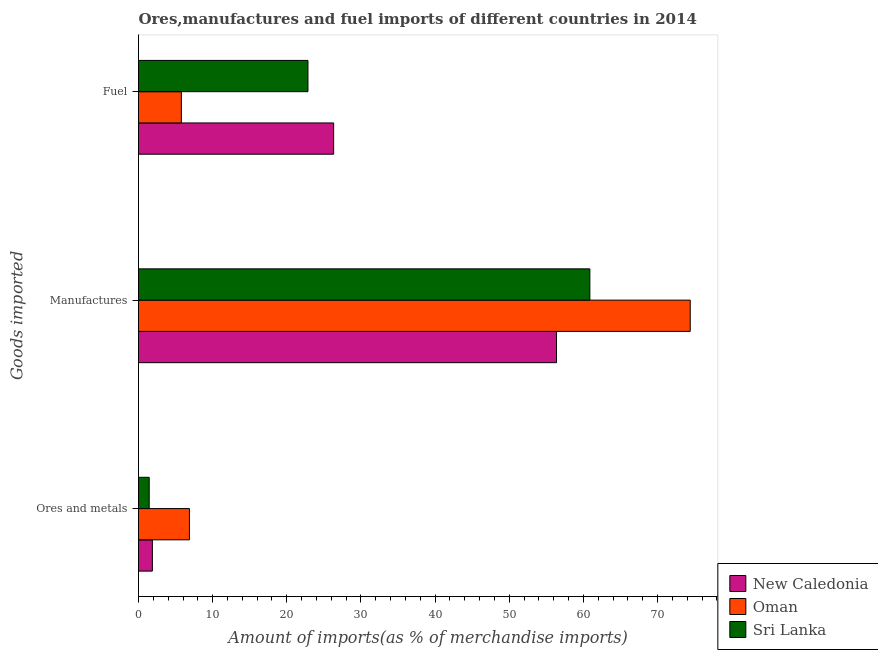How many groups of bars are there?
Your answer should be compact. 3. How many bars are there on the 1st tick from the bottom?
Your answer should be very brief. 3. What is the label of the 1st group of bars from the top?
Your answer should be very brief. Fuel. What is the percentage of manufactures imports in New Caledonia?
Offer a terse response. 56.38. Across all countries, what is the maximum percentage of fuel imports?
Provide a succinct answer. 26.32. Across all countries, what is the minimum percentage of ores and metals imports?
Make the answer very short. 1.44. In which country was the percentage of fuel imports maximum?
Provide a succinct answer. New Caledonia. In which country was the percentage of ores and metals imports minimum?
Your answer should be very brief. Sri Lanka. What is the total percentage of ores and metals imports in the graph?
Make the answer very short. 10.18. What is the difference between the percentage of ores and metals imports in Sri Lanka and that in New Caledonia?
Provide a short and direct response. -0.43. What is the difference between the percentage of ores and metals imports in Sri Lanka and the percentage of fuel imports in New Caledonia?
Provide a succinct answer. -24.88. What is the average percentage of ores and metals imports per country?
Offer a very short reply. 3.39. What is the difference between the percentage of fuel imports and percentage of manufactures imports in Oman?
Give a very brief answer. -68.63. In how many countries, is the percentage of fuel imports greater than 38 %?
Provide a succinct answer. 0. What is the ratio of the percentage of ores and metals imports in Sri Lanka to that in New Caledonia?
Offer a terse response. 0.77. Is the difference between the percentage of ores and metals imports in New Caledonia and Sri Lanka greater than the difference between the percentage of fuel imports in New Caledonia and Sri Lanka?
Give a very brief answer. No. What is the difference between the highest and the second highest percentage of ores and metals imports?
Provide a succinct answer. 5. What is the difference between the highest and the lowest percentage of ores and metals imports?
Your response must be concise. 5.43. What does the 3rd bar from the top in Ores and metals represents?
Offer a terse response. New Caledonia. What does the 2nd bar from the bottom in Manufactures represents?
Your answer should be very brief. Oman. Is it the case that in every country, the sum of the percentage of ores and metals imports and percentage of manufactures imports is greater than the percentage of fuel imports?
Offer a terse response. Yes. How many bars are there?
Provide a succinct answer. 9. How many countries are there in the graph?
Make the answer very short. 3. Are the values on the major ticks of X-axis written in scientific E-notation?
Provide a succinct answer. No. Does the graph contain grids?
Offer a terse response. No. How many legend labels are there?
Your response must be concise. 3. What is the title of the graph?
Give a very brief answer. Ores,manufactures and fuel imports of different countries in 2014. What is the label or title of the X-axis?
Provide a succinct answer. Amount of imports(as % of merchandise imports). What is the label or title of the Y-axis?
Your response must be concise. Goods imported. What is the Amount of imports(as % of merchandise imports) of New Caledonia in Ores and metals?
Provide a succinct answer. 1.87. What is the Amount of imports(as % of merchandise imports) in Oman in Ores and metals?
Your answer should be compact. 6.87. What is the Amount of imports(as % of merchandise imports) in Sri Lanka in Ores and metals?
Provide a short and direct response. 1.44. What is the Amount of imports(as % of merchandise imports) in New Caledonia in Manufactures?
Provide a succinct answer. 56.38. What is the Amount of imports(as % of merchandise imports) in Oman in Manufactures?
Ensure brevity in your answer.  74.41. What is the Amount of imports(as % of merchandise imports) in Sri Lanka in Manufactures?
Your answer should be compact. 60.88. What is the Amount of imports(as % of merchandise imports) of New Caledonia in Fuel?
Ensure brevity in your answer.  26.32. What is the Amount of imports(as % of merchandise imports) in Oman in Fuel?
Your response must be concise. 5.78. What is the Amount of imports(as % of merchandise imports) of Sri Lanka in Fuel?
Your response must be concise. 22.85. Across all Goods imported, what is the maximum Amount of imports(as % of merchandise imports) in New Caledonia?
Provide a succinct answer. 56.38. Across all Goods imported, what is the maximum Amount of imports(as % of merchandise imports) in Oman?
Offer a terse response. 74.41. Across all Goods imported, what is the maximum Amount of imports(as % of merchandise imports) in Sri Lanka?
Your answer should be very brief. 60.88. Across all Goods imported, what is the minimum Amount of imports(as % of merchandise imports) in New Caledonia?
Provide a short and direct response. 1.87. Across all Goods imported, what is the minimum Amount of imports(as % of merchandise imports) in Oman?
Ensure brevity in your answer.  5.78. Across all Goods imported, what is the minimum Amount of imports(as % of merchandise imports) of Sri Lanka?
Your answer should be very brief. 1.44. What is the total Amount of imports(as % of merchandise imports) of New Caledonia in the graph?
Make the answer very short. 84.57. What is the total Amount of imports(as % of merchandise imports) of Oman in the graph?
Make the answer very short. 87.06. What is the total Amount of imports(as % of merchandise imports) of Sri Lanka in the graph?
Provide a succinct answer. 85.17. What is the difference between the Amount of imports(as % of merchandise imports) of New Caledonia in Ores and metals and that in Manufactures?
Give a very brief answer. -54.51. What is the difference between the Amount of imports(as % of merchandise imports) in Oman in Ores and metals and that in Manufactures?
Your response must be concise. -67.54. What is the difference between the Amount of imports(as % of merchandise imports) of Sri Lanka in Ores and metals and that in Manufactures?
Keep it short and to the point. -59.43. What is the difference between the Amount of imports(as % of merchandise imports) in New Caledonia in Ores and metals and that in Fuel?
Offer a very short reply. -24.45. What is the difference between the Amount of imports(as % of merchandise imports) of Oman in Ores and metals and that in Fuel?
Provide a succinct answer. 1.09. What is the difference between the Amount of imports(as % of merchandise imports) of Sri Lanka in Ores and metals and that in Fuel?
Your answer should be very brief. -21.41. What is the difference between the Amount of imports(as % of merchandise imports) in New Caledonia in Manufactures and that in Fuel?
Make the answer very short. 30.06. What is the difference between the Amount of imports(as % of merchandise imports) in Oman in Manufactures and that in Fuel?
Your response must be concise. 68.63. What is the difference between the Amount of imports(as % of merchandise imports) in Sri Lanka in Manufactures and that in Fuel?
Offer a very short reply. 38.02. What is the difference between the Amount of imports(as % of merchandise imports) of New Caledonia in Ores and metals and the Amount of imports(as % of merchandise imports) of Oman in Manufactures?
Offer a terse response. -72.54. What is the difference between the Amount of imports(as % of merchandise imports) of New Caledonia in Ores and metals and the Amount of imports(as % of merchandise imports) of Sri Lanka in Manufactures?
Provide a succinct answer. -59.01. What is the difference between the Amount of imports(as % of merchandise imports) of Oman in Ores and metals and the Amount of imports(as % of merchandise imports) of Sri Lanka in Manufactures?
Provide a short and direct response. -54.01. What is the difference between the Amount of imports(as % of merchandise imports) of New Caledonia in Ores and metals and the Amount of imports(as % of merchandise imports) of Oman in Fuel?
Provide a short and direct response. -3.91. What is the difference between the Amount of imports(as % of merchandise imports) in New Caledonia in Ores and metals and the Amount of imports(as % of merchandise imports) in Sri Lanka in Fuel?
Make the answer very short. -20.98. What is the difference between the Amount of imports(as % of merchandise imports) of Oman in Ores and metals and the Amount of imports(as % of merchandise imports) of Sri Lanka in Fuel?
Offer a very short reply. -15.98. What is the difference between the Amount of imports(as % of merchandise imports) of New Caledonia in Manufactures and the Amount of imports(as % of merchandise imports) of Oman in Fuel?
Your answer should be compact. 50.6. What is the difference between the Amount of imports(as % of merchandise imports) of New Caledonia in Manufactures and the Amount of imports(as % of merchandise imports) of Sri Lanka in Fuel?
Offer a very short reply. 33.53. What is the difference between the Amount of imports(as % of merchandise imports) of Oman in Manufactures and the Amount of imports(as % of merchandise imports) of Sri Lanka in Fuel?
Offer a very short reply. 51.56. What is the average Amount of imports(as % of merchandise imports) in New Caledonia per Goods imported?
Give a very brief answer. 28.19. What is the average Amount of imports(as % of merchandise imports) of Oman per Goods imported?
Keep it short and to the point. 29.02. What is the average Amount of imports(as % of merchandise imports) in Sri Lanka per Goods imported?
Offer a terse response. 28.39. What is the difference between the Amount of imports(as % of merchandise imports) in New Caledonia and Amount of imports(as % of merchandise imports) in Oman in Ores and metals?
Give a very brief answer. -5. What is the difference between the Amount of imports(as % of merchandise imports) of New Caledonia and Amount of imports(as % of merchandise imports) of Sri Lanka in Ores and metals?
Make the answer very short. 0.43. What is the difference between the Amount of imports(as % of merchandise imports) of Oman and Amount of imports(as % of merchandise imports) of Sri Lanka in Ores and metals?
Provide a succinct answer. 5.43. What is the difference between the Amount of imports(as % of merchandise imports) in New Caledonia and Amount of imports(as % of merchandise imports) in Oman in Manufactures?
Your answer should be compact. -18.03. What is the difference between the Amount of imports(as % of merchandise imports) in New Caledonia and Amount of imports(as % of merchandise imports) in Sri Lanka in Manufactures?
Your response must be concise. -4.5. What is the difference between the Amount of imports(as % of merchandise imports) in Oman and Amount of imports(as % of merchandise imports) in Sri Lanka in Manufactures?
Your response must be concise. 13.54. What is the difference between the Amount of imports(as % of merchandise imports) in New Caledonia and Amount of imports(as % of merchandise imports) in Oman in Fuel?
Provide a succinct answer. 20.54. What is the difference between the Amount of imports(as % of merchandise imports) in New Caledonia and Amount of imports(as % of merchandise imports) in Sri Lanka in Fuel?
Provide a short and direct response. 3.47. What is the difference between the Amount of imports(as % of merchandise imports) of Oman and Amount of imports(as % of merchandise imports) of Sri Lanka in Fuel?
Your answer should be compact. -17.07. What is the ratio of the Amount of imports(as % of merchandise imports) of New Caledonia in Ores and metals to that in Manufactures?
Offer a very short reply. 0.03. What is the ratio of the Amount of imports(as % of merchandise imports) of Oman in Ores and metals to that in Manufactures?
Ensure brevity in your answer.  0.09. What is the ratio of the Amount of imports(as % of merchandise imports) in Sri Lanka in Ores and metals to that in Manufactures?
Give a very brief answer. 0.02. What is the ratio of the Amount of imports(as % of merchandise imports) in New Caledonia in Ores and metals to that in Fuel?
Offer a very short reply. 0.07. What is the ratio of the Amount of imports(as % of merchandise imports) in Oman in Ores and metals to that in Fuel?
Keep it short and to the point. 1.19. What is the ratio of the Amount of imports(as % of merchandise imports) in Sri Lanka in Ores and metals to that in Fuel?
Offer a very short reply. 0.06. What is the ratio of the Amount of imports(as % of merchandise imports) in New Caledonia in Manufactures to that in Fuel?
Provide a succinct answer. 2.14. What is the ratio of the Amount of imports(as % of merchandise imports) of Oman in Manufactures to that in Fuel?
Provide a succinct answer. 12.88. What is the ratio of the Amount of imports(as % of merchandise imports) of Sri Lanka in Manufactures to that in Fuel?
Your answer should be compact. 2.66. What is the difference between the highest and the second highest Amount of imports(as % of merchandise imports) in New Caledonia?
Make the answer very short. 30.06. What is the difference between the highest and the second highest Amount of imports(as % of merchandise imports) of Oman?
Your response must be concise. 67.54. What is the difference between the highest and the second highest Amount of imports(as % of merchandise imports) in Sri Lanka?
Offer a very short reply. 38.02. What is the difference between the highest and the lowest Amount of imports(as % of merchandise imports) in New Caledonia?
Ensure brevity in your answer.  54.51. What is the difference between the highest and the lowest Amount of imports(as % of merchandise imports) of Oman?
Ensure brevity in your answer.  68.63. What is the difference between the highest and the lowest Amount of imports(as % of merchandise imports) in Sri Lanka?
Offer a terse response. 59.43. 